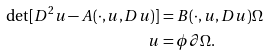Convert formula to latex. <formula><loc_0><loc_0><loc_500><loc_500>\det [ D ^ { 2 } u - A ( \cdot , u , D u ) ] & = B ( \cdot , u , D u ) \Omega \\ u & = \phi \partial \Omega .</formula> 